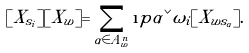<formula> <loc_0><loc_0><loc_500><loc_500>[ X _ { s _ { i } } ] [ X _ { w } ] = \sum _ { \alpha \in A _ { w } ^ { n } } \i p { \alpha ^ { \vee } } { \omega _ { i } } [ X _ { w s _ { \alpha } } ] .</formula> 